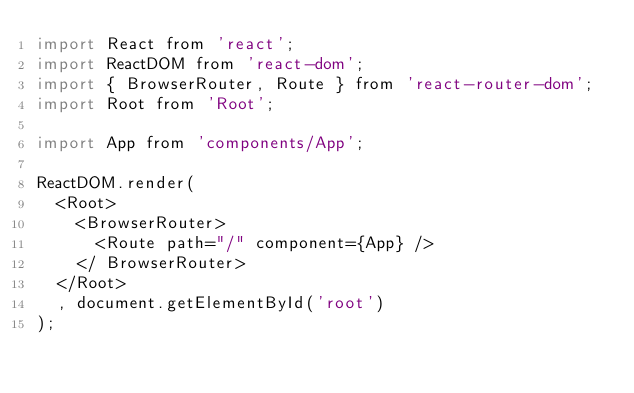Convert code to text. <code><loc_0><loc_0><loc_500><loc_500><_JavaScript_>import React from 'react';
import ReactDOM from 'react-dom';
import { BrowserRouter, Route } from 'react-router-dom';
import Root from 'Root';

import App from 'components/App';

ReactDOM.render(
  <Root>
    <BrowserRouter>
      <Route path="/" component={App} />
    </ BrowserRouter>
  </Root>
  , document.getElementById('root')
);
</code> 